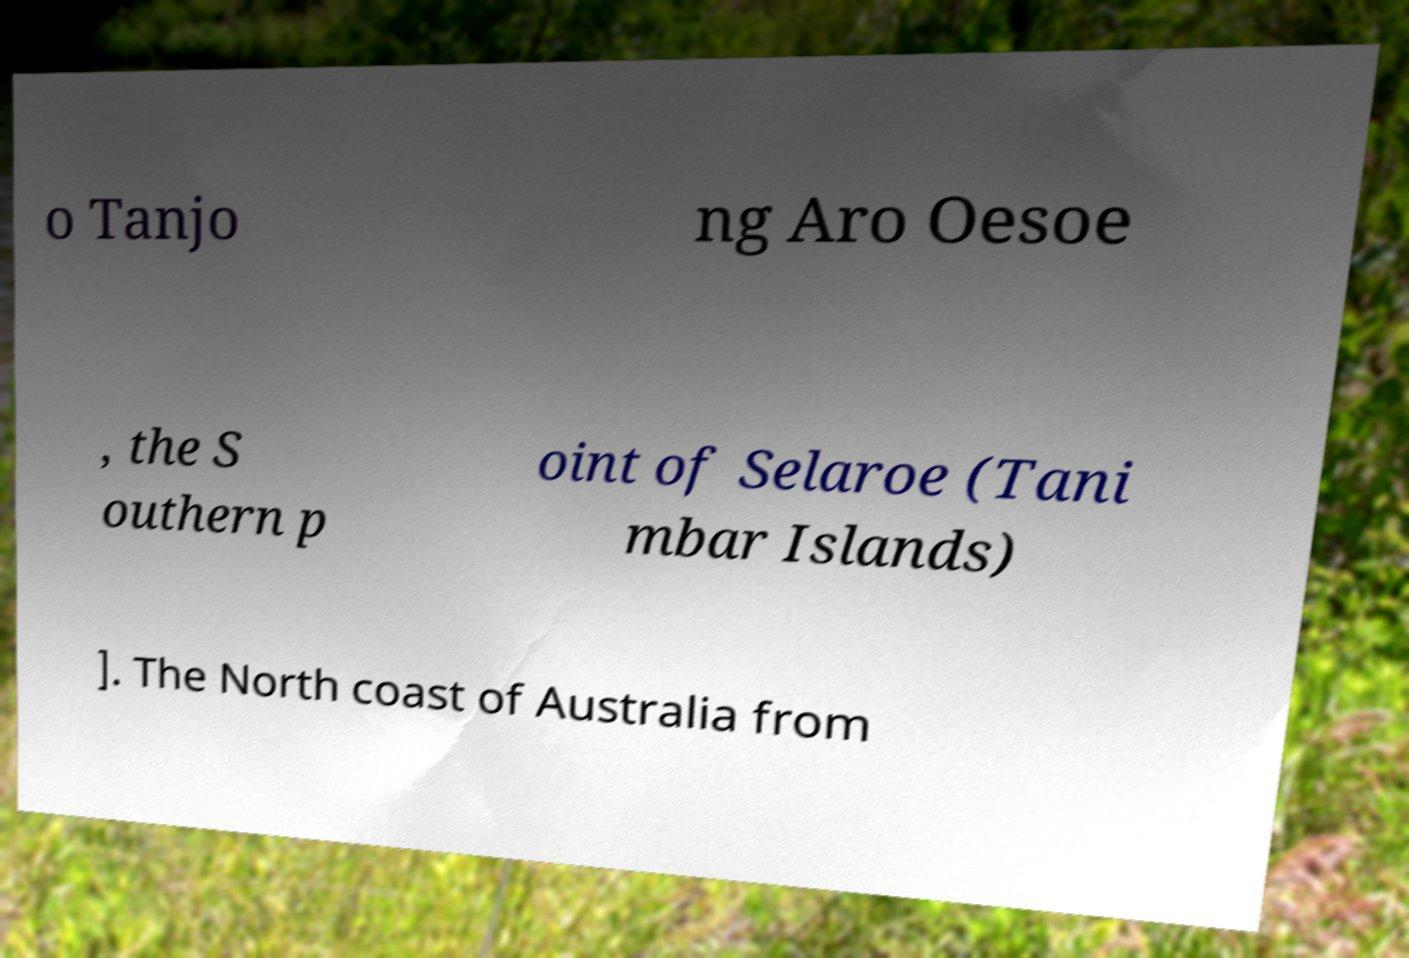Please read and relay the text visible in this image. What does it say? o Tanjo ng Aro Oesoe , the S outhern p oint of Selaroe (Tani mbar Islands) ]. The North coast of Australia from 